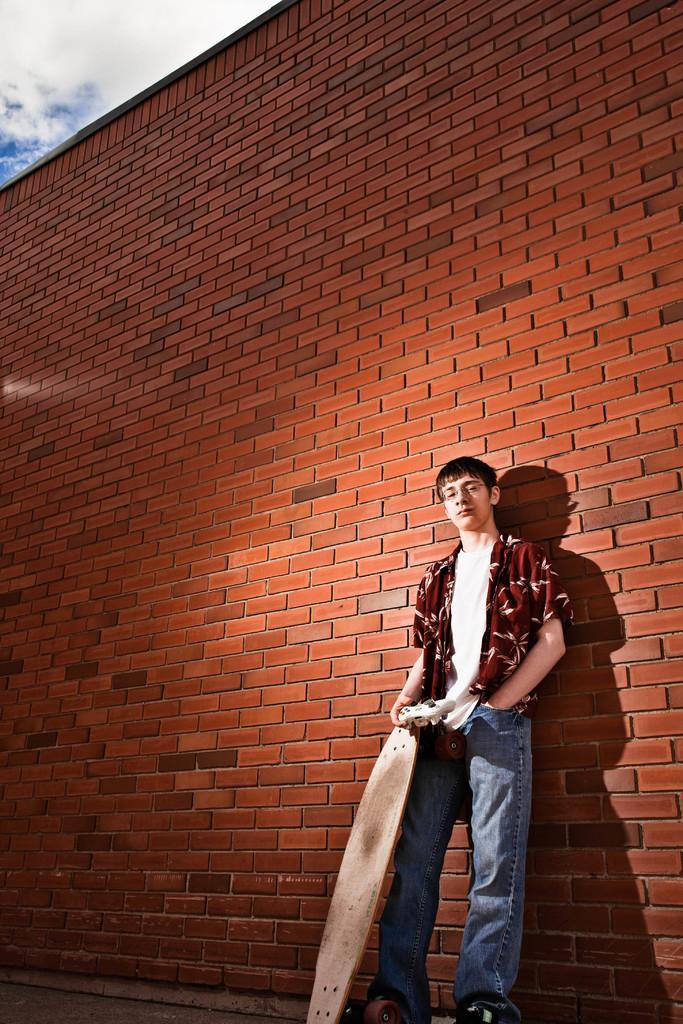In one or two sentences, can you explain what this image depicts? In this image we can see a man standing beside a wall holding a skating board. On the top of the image we can see the sky which looks cloudy. 